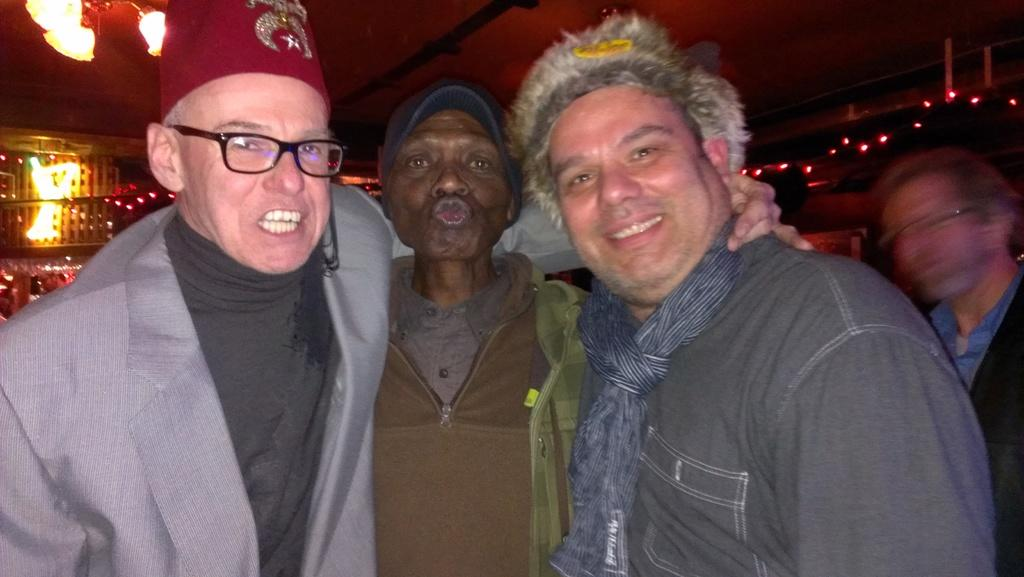What can be observed about the people in the image? There are people standing in the image, and most of them are men. Where are the people standing? The people are standing on the floor. What is hanging in the top left side of the image? There is a chandelier hanging in the top left side of the image. How is the chandelier attached? The chandelier is attached to the ceiling. What type of celery can be seen supporting the chandelier in the image? There is no celery present in the image, and celery is not used to support the chandelier. 